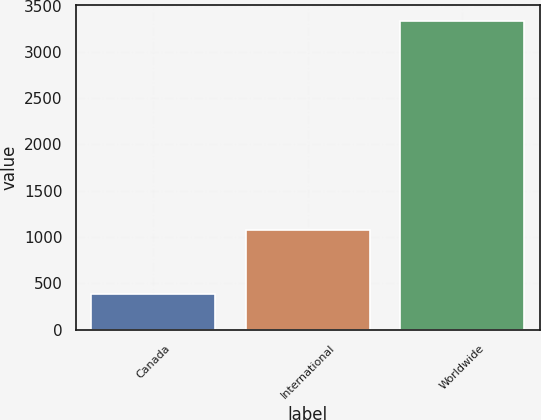Convert chart to OTSL. <chart><loc_0><loc_0><loc_500><loc_500><bar_chart><fcel>Canada<fcel>International<fcel>Worldwide<nl><fcel>379<fcel>1079<fcel>3336<nl></chart> 